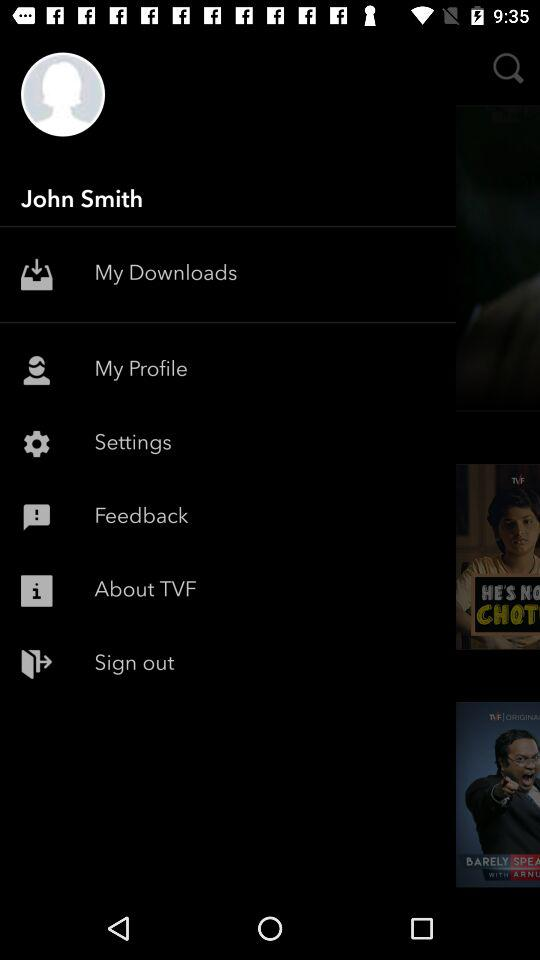What is the user name? The user name is John Smith. 